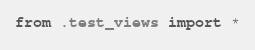<code> <loc_0><loc_0><loc_500><loc_500><_Python_>from .test_views import *
</code> 